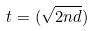<formula> <loc_0><loc_0><loc_500><loc_500>t = ( \sqrt { 2 n d } )</formula> 